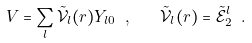Convert formula to latex. <formula><loc_0><loc_0><loc_500><loc_500>V = \sum _ { l } \tilde { \mathcal { V } } _ { l } ( r ) Y _ { l 0 } \ , \quad \tilde { \mathcal { V } } _ { l } ( r ) = \tilde { \mathcal { E } } _ { 2 } ^ { l } \ .</formula> 